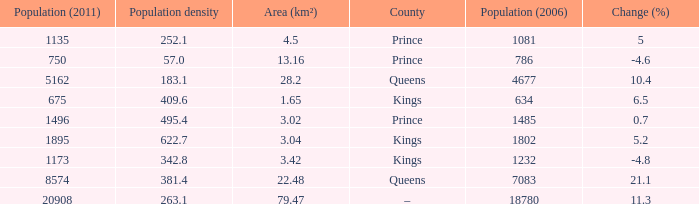What is the Population density that has a Change (%) higher than 10.4, and a Population (2011) less than 8574, in the County of Queens? None. 